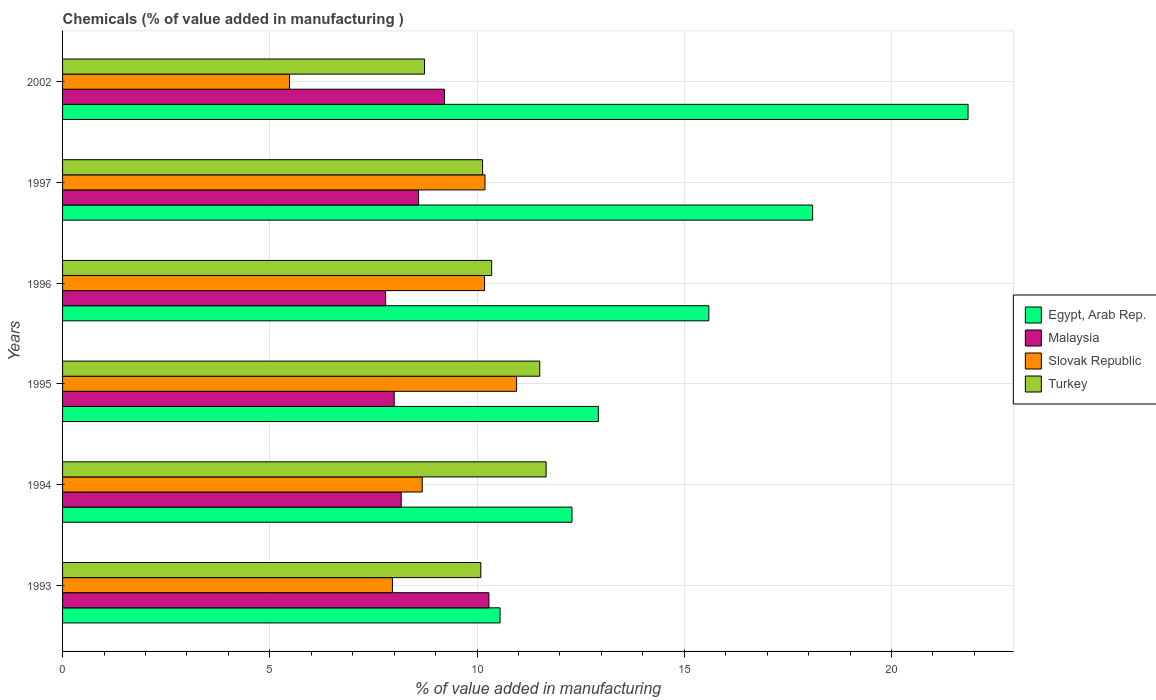How many different coloured bars are there?
Keep it short and to the point. 4. How many bars are there on the 4th tick from the top?
Make the answer very short. 4. How many bars are there on the 4th tick from the bottom?
Provide a succinct answer. 4. What is the value added in manufacturing chemicals in Malaysia in 1997?
Make the answer very short. 8.59. Across all years, what is the maximum value added in manufacturing chemicals in Egypt, Arab Rep.?
Offer a very short reply. 21.85. Across all years, what is the minimum value added in manufacturing chemicals in Turkey?
Ensure brevity in your answer.  8.73. What is the total value added in manufacturing chemicals in Egypt, Arab Rep. in the graph?
Your answer should be very brief. 91.31. What is the difference between the value added in manufacturing chemicals in Malaysia in 1993 and that in 2002?
Your response must be concise. 1.07. What is the difference between the value added in manufacturing chemicals in Slovak Republic in 1997 and the value added in manufacturing chemicals in Turkey in 2002?
Give a very brief answer. 1.46. What is the average value added in manufacturing chemicals in Egypt, Arab Rep. per year?
Your response must be concise. 15.22. In the year 1997, what is the difference between the value added in manufacturing chemicals in Turkey and value added in manufacturing chemicals in Egypt, Arab Rep.?
Offer a terse response. -7.96. What is the ratio of the value added in manufacturing chemicals in Malaysia in 1995 to that in 2002?
Your answer should be very brief. 0.87. Is the value added in manufacturing chemicals in Egypt, Arab Rep. in 1996 less than that in 2002?
Your answer should be very brief. Yes. Is the difference between the value added in manufacturing chemicals in Turkey in 1995 and 1996 greater than the difference between the value added in manufacturing chemicals in Egypt, Arab Rep. in 1995 and 1996?
Your answer should be very brief. Yes. What is the difference between the highest and the second highest value added in manufacturing chemicals in Slovak Republic?
Offer a terse response. 0.76. What is the difference between the highest and the lowest value added in manufacturing chemicals in Egypt, Arab Rep.?
Your answer should be very brief. 11.29. What does the 3rd bar from the top in 1993 represents?
Offer a very short reply. Malaysia. What does the 3rd bar from the bottom in 1995 represents?
Offer a very short reply. Slovak Republic. How many years are there in the graph?
Your response must be concise. 6. Where does the legend appear in the graph?
Ensure brevity in your answer.  Center right. What is the title of the graph?
Keep it short and to the point. Chemicals (% of value added in manufacturing ). What is the label or title of the X-axis?
Provide a short and direct response. % of value added in manufacturing. What is the % of value added in manufacturing of Egypt, Arab Rep. in 1993?
Your answer should be compact. 10.56. What is the % of value added in manufacturing of Malaysia in 1993?
Give a very brief answer. 10.29. What is the % of value added in manufacturing in Slovak Republic in 1993?
Give a very brief answer. 7.96. What is the % of value added in manufacturing in Turkey in 1993?
Offer a very short reply. 10.09. What is the % of value added in manufacturing in Egypt, Arab Rep. in 1994?
Your response must be concise. 12.29. What is the % of value added in manufacturing in Malaysia in 1994?
Offer a very short reply. 8.17. What is the % of value added in manufacturing in Slovak Republic in 1994?
Provide a succinct answer. 8.68. What is the % of value added in manufacturing in Turkey in 1994?
Ensure brevity in your answer.  11.67. What is the % of value added in manufacturing in Egypt, Arab Rep. in 1995?
Your answer should be very brief. 12.93. What is the % of value added in manufacturing of Malaysia in 1995?
Make the answer very short. 8. What is the % of value added in manufacturing in Slovak Republic in 1995?
Keep it short and to the point. 10.96. What is the % of value added in manufacturing of Turkey in 1995?
Offer a terse response. 11.51. What is the % of value added in manufacturing in Egypt, Arab Rep. in 1996?
Ensure brevity in your answer.  15.59. What is the % of value added in manufacturing in Malaysia in 1996?
Offer a terse response. 7.79. What is the % of value added in manufacturing in Slovak Republic in 1996?
Provide a succinct answer. 10.18. What is the % of value added in manufacturing of Turkey in 1996?
Your answer should be compact. 10.35. What is the % of value added in manufacturing of Egypt, Arab Rep. in 1997?
Provide a succinct answer. 18.1. What is the % of value added in manufacturing of Malaysia in 1997?
Ensure brevity in your answer.  8.59. What is the % of value added in manufacturing in Slovak Republic in 1997?
Your response must be concise. 10.19. What is the % of value added in manufacturing of Turkey in 1997?
Provide a succinct answer. 10.13. What is the % of value added in manufacturing in Egypt, Arab Rep. in 2002?
Make the answer very short. 21.85. What is the % of value added in manufacturing in Malaysia in 2002?
Your answer should be compact. 9.21. What is the % of value added in manufacturing in Slovak Republic in 2002?
Ensure brevity in your answer.  5.48. What is the % of value added in manufacturing in Turkey in 2002?
Provide a succinct answer. 8.73. Across all years, what is the maximum % of value added in manufacturing of Egypt, Arab Rep.?
Your response must be concise. 21.85. Across all years, what is the maximum % of value added in manufacturing in Malaysia?
Your answer should be very brief. 10.29. Across all years, what is the maximum % of value added in manufacturing of Slovak Republic?
Offer a very short reply. 10.96. Across all years, what is the maximum % of value added in manufacturing of Turkey?
Keep it short and to the point. 11.67. Across all years, what is the minimum % of value added in manufacturing of Egypt, Arab Rep.?
Give a very brief answer. 10.56. Across all years, what is the minimum % of value added in manufacturing of Malaysia?
Offer a terse response. 7.79. Across all years, what is the minimum % of value added in manufacturing of Slovak Republic?
Your answer should be compact. 5.48. Across all years, what is the minimum % of value added in manufacturing of Turkey?
Make the answer very short. 8.73. What is the total % of value added in manufacturing in Egypt, Arab Rep. in the graph?
Offer a terse response. 91.31. What is the total % of value added in manufacturing of Malaysia in the graph?
Your response must be concise. 52.06. What is the total % of value added in manufacturing in Slovak Republic in the graph?
Your response must be concise. 53.44. What is the total % of value added in manufacturing in Turkey in the graph?
Provide a succinct answer. 62.49. What is the difference between the % of value added in manufacturing in Egypt, Arab Rep. in 1993 and that in 1994?
Keep it short and to the point. -1.74. What is the difference between the % of value added in manufacturing in Malaysia in 1993 and that in 1994?
Provide a succinct answer. 2.12. What is the difference between the % of value added in manufacturing of Slovak Republic in 1993 and that in 1994?
Keep it short and to the point. -0.72. What is the difference between the % of value added in manufacturing of Turkey in 1993 and that in 1994?
Your response must be concise. -1.58. What is the difference between the % of value added in manufacturing in Egypt, Arab Rep. in 1993 and that in 1995?
Provide a succinct answer. -2.37. What is the difference between the % of value added in manufacturing in Malaysia in 1993 and that in 1995?
Provide a short and direct response. 2.29. What is the difference between the % of value added in manufacturing in Slovak Republic in 1993 and that in 1995?
Ensure brevity in your answer.  -3. What is the difference between the % of value added in manufacturing of Turkey in 1993 and that in 1995?
Keep it short and to the point. -1.42. What is the difference between the % of value added in manufacturing in Egypt, Arab Rep. in 1993 and that in 1996?
Your answer should be very brief. -5.04. What is the difference between the % of value added in manufacturing in Malaysia in 1993 and that in 1996?
Your answer should be very brief. 2.49. What is the difference between the % of value added in manufacturing of Slovak Republic in 1993 and that in 1996?
Your answer should be compact. -2.22. What is the difference between the % of value added in manufacturing in Turkey in 1993 and that in 1996?
Give a very brief answer. -0.26. What is the difference between the % of value added in manufacturing of Egypt, Arab Rep. in 1993 and that in 1997?
Keep it short and to the point. -7.54. What is the difference between the % of value added in manufacturing in Malaysia in 1993 and that in 1997?
Ensure brevity in your answer.  1.7. What is the difference between the % of value added in manufacturing of Slovak Republic in 1993 and that in 1997?
Your answer should be compact. -2.23. What is the difference between the % of value added in manufacturing of Turkey in 1993 and that in 1997?
Your answer should be compact. -0.04. What is the difference between the % of value added in manufacturing of Egypt, Arab Rep. in 1993 and that in 2002?
Provide a short and direct response. -11.29. What is the difference between the % of value added in manufacturing of Malaysia in 1993 and that in 2002?
Ensure brevity in your answer.  1.07. What is the difference between the % of value added in manufacturing of Slovak Republic in 1993 and that in 2002?
Offer a terse response. 2.48. What is the difference between the % of value added in manufacturing in Turkey in 1993 and that in 2002?
Provide a succinct answer. 1.36. What is the difference between the % of value added in manufacturing of Egypt, Arab Rep. in 1994 and that in 1995?
Keep it short and to the point. -0.64. What is the difference between the % of value added in manufacturing in Malaysia in 1994 and that in 1995?
Ensure brevity in your answer.  0.17. What is the difference between the % of value added in manufacturing in Slovak Republic in 1994 and that in 1995?
Give a very brief answer. -2.28. What is the difference between the % of value added in manufacturing in Turkey in 1994 and that in 1995?
Offer a terse response. 0.15. What is the difference between the % of value added in manufacturing in Egypt, Arab Rep. in 1994 and that in 1996?
Provide a succinct answer. -3.3. What is the difference between the % of value added in manufacturing in Malaysia in 1994 and that in 1996?
Ensure brevity in your answer.  0.38. What is the difference between the % of value added in manufacturing of Slovak Republic in 1994 and that in 1996?
Provide a succinct answer. -1.51. What is the difference between the % of value added in manufacturing of Turkey in 1994 and that in 1996?
Provide a succinct answer. 1.31. What is the difference between the % of value added in manufacturing in Egypt, Arab Rep. in 1994 and that in 1997?
Offer a very short reply. -5.81. What is the difference between the % of value added in manufacturing in Malaysia in 1994 and that in 1997?
Offer a very short reply. -0.42. What is the difference between the % of value added in manufacturing of Slovak Republic in 1994 and that in 1997?
Ensure brevity in your answer.  -1.51. What is the difference between the % of value added in manufacturing of Turkey in 1994 and that in 1997?
Make the answer very short. 1.53. What is the difference between the % of value added in manufacturing of Egypt, Arab Rep. in 1994 and that in 2002?
Offer a terse response. -9.56. What is the difference between the % of value added in manufacturing of Malaysia in 1994 and that in 2002?
Provide a succinct answer. -1.04. What is the difference between the % of value added in manufacturing in Slovak Republic in 1994 and that in 2002?
Your answer should be very brief. 3.2. What is the difference between the % of value added in manufacturing of Turkey in 1994 and that in 2002?
Offer a very short reply. 2.93. What is the difference between the % of value added in manufacturing of Egypt, Arab Rep. in 1995 and that in 1996?
Provide a succinct answer. -2.66. What is the difference between the % of value added in manufacturing of Malaysia in 1995 and that in 1996?
Your answer should be very brief. 0.21. What is the difference between the % of value added in manufacturing in Slovak Republic in 1995 and that in 1996?
Offer a terse response. 0.77. What is the difference between the % of value added in manufacturing of Turkey in 1995 and that in 1996?
Your response must be concise. 1.16. What is the difference between the % of value added in manufacturing of Egypt, Arab Rep. in 1995 and that in 1997?
Offer a terse response. -5.17. What is the difference between the % of value added in manufacturing of Malaysia in 1995 and that in 1997?
Keep it short and to the point. -0.59. What is the difference between the % of value added in manufacturing of Slovak Republic in 1995 and that in 1997?
Make the answer very short. 0.76. What is the difference between the % of value added in manufacturing of Turkey in 1995 and that in 1997?
Your response must be concise. 1.38. What is the difference between the % of value added in manufacturing of Egypt, Arab Rep. in 1995 and that in 2002?
Provide a short and direct response. -8.92. What is the difference between the % of value added in manufacturing in Malaysia in 1995 and that in 2002?
Make the answer very short. -1.21. What is the difference between the % of value added in manufacturing in Slovak Republic in 1995 and that in 2002?
Offer a terse response. 5.48. What is the difference between the % of value added in manufacturing of Turkey in 1995 and that in 2002?
Offer a very short reply. 2.78. What is the difference between the % of value added in manufacturing of Egypt, Arab Rep. in 1996 and that in 1997?
Make the answer very short. -2.5. What is the difference between the % of value added in manufacturing of Malaysia in 1996 and that in 1997?
Provide a short and direct response. -0.79. What is the difference between the % of value added in manufacturing of Slovak Republic in 1996 and that in 1997?
Provide a short and direct response. -0.01. What is the difference between the % of value added in manufacturing of Turkey in 1996 and that in 1997?
Offer a terse response. 0.22. What is the difference between the % of value added in manufacturing in Egypt, Arab Rep. in 1996 and that in 2002?
Offer a terse response. -6.26. What is the difference between the % of value added in manufacturing in Malaysia in 1996 and that in 2002?
Your answer should be very brief. -1.42. What is the difference between the % of value added in manufacturing of Slovak Republic in 1996 and that in 2002?
Your answer should be very brief. 4.71. What is the difference between the % of value added in manufacturing of Turkey in 1996 and that in 2002?
Provide a succinct answer. 1.62. What is the difference between the % of value added in manufacturing in Egypt, Arab Rep. in 1997 and that in 2002?
Your answer should be very brief. -3.75. What is the difference between the % of value added in manufacturing of Malaysia in 1997 and that in 2002?
Your answer should be compact. -0.63. What is the difference between the % of value added in manufacturing in Slovak Republic in 1997 and that in 2002?
Your answer should be compact. 4.72. What is the difference between the % of value added in manufacturing of Turkey in 1997 and that in 2002?
Ensure brevity in your answer.  1.4. What is the difference between the % of value added in manufacturing of Egypt, Arab Rep. in 1993 and the % of value added in manufacturing of Malaysia in 1994?
Offer a very short reply. 2.39. What is the difference between the % of value added in manufacturing in Egypt, Arab Rep. in 1993 and the % of value added in manufacturing in Slovak Republic in 1994?
Your response must be concise. 1.88. What is the difference between the % of value added in manufacturing in Egypt, Arab Rep. in 1993 and the % of value added in manufacturing in Turkey in 1994?
Offer a very short reply. -1.11. What is the difference between the % of value added in manufacturing of Malaysia in 1993 and the % of value added in manufacturing of Slovak Republic in 1994?
Provide a short and direct response. 1.61. What is the difference between the % of value added in manufacturing of Malaysia in 1993 and the % of value added in manufacturing of Turkey in 1994?
Offer a very short reply. -1.38. What is the difference between the % of value added in manufacturing in Slovak Republic in 1993 and the % of value added in manufacturing in Turkey in 1994?
Your answer should be very brief. -3.71. What is the difference between the % of value added in manufacturing of Egypt, Arab Rep. in 1993 and the % of value added in manufacturing of Malaysia in 1995?
Provide a succinct answer. 2.55. What is the difference between the % of value added in manufacturing in Egypt, Arab Rep. in 1993 and the % of value added in manufacturing in Slovak Republic in 1995?
Provide a short and direct response. -0.4. What is the difference between the % of value added in manufacturing of Egypt, Arab Rep. in 1993 and the % of value added in manufacturing of Turkey in 1995?
Provide a succinct answer. -0.96. What is the difference between the % of value added in manufacturing in Malaysia in 1993 and the % of value added in manufacturing in Slovak Republic in 1995?
Your answer should be very brief. -0.67. What is the difference between the % of value added in manufacturing in Malaysia in 1993 and the % of value added in manufacturing in Turkey in 1995?
Make the answer very short. -1.23. What is the difference between the % of value added in manufacturing of Slovak Republic in 1993 and the % of value added in manufacturing of Turkey in 1995?
Provide a short and direct response. -3.55. What is the difference between the % of value added in manufacturing of Egypt, Arab Rep. in 1993 and the % of value added in manufacturing of Malaysia in 1996?
Provide a short and direct response. 2.76. What is the difference between the % of value added in manufacturing in Egypt, Arab Rep. in 1993 and the % of value added in manufacturing in Slovak Republic in 1996?
Provide a short and direct response. 0.37. What is the difference between the % of value added in manufacturing in Egypt, Arab Rep. in 1993 and the % of value added in manufacturing in Turkey in 1996?
Your answer should be very brief. 0.2. What is the difference between the % of value added in manufacturing in Malaysia in 1993 and the % of value added in manufacturing in Slovak Republic in 1996?
Offer a very short reply. 0.1. What is the difference between the % of value added in manufacturing in Malaysia in 1993 and the % of value added in manufacturing in Turkey in 1996?
Make the answer very short. -0.07. What is the difference between the % of value added in manufacturing in Slovak Republic in 1993 and the % of value added in manufacturing in Turkey in 1996?
Ensure brevity in your answer.  -2.39. What is the difference between the % of value added in manufacturing of Egypt, Arab Rep. in 1993 and the % of value added in manufacturing of Malaysia in 1997?
Provide a succinct answer. 1.97. What is the difference between the % of value added in manufacturing in Egypt, Arab Rep. in 1993 and the % of value added in manufacturing in Slovak Republic in 1997?
Give a very brief answer. 0.36. What is the difference between the % of value added in manufacturing in Egypt, Arab Rep. in 1993 and the % of value added in manufacturing in Turkey in 1997?
Provide a short and direct response. 0.42. What is the difference between the % of value added in manufacturing of Malaysia in 1993 and the % of value added in manufacturing of Slovak Republic in 1997?
Your response must be concise. 0.1. What is the difference between the % of value added in manufacturing in Malaysia in 1993 and the % of value added in manufacturing in Turkey in 1997?
Your answer should be very brief. 0.15. What is the difference between the % of value added in manufacturing of Slovak Republic in 1993 and the % of value added in manufacturing of Turkey in 1997?
Keep it short and to the point. -2.18. What is the difference between the % of value added in manufacturing of Egypt, Arab Rep. in 1993 and the % of value added in manufacturing of Malaysia in 2002?
Offer a very short reply. 1.34. What is the difference between the % of value added in manufacturing in Egypt, Arab Rep. in 1993 and the % of value added in manufacturing in Slovak Republic in 2002?
Offer a terse response. 5.08. What is the difference between the % of value added in manufacturing of Egypt, Arab Rep. in 1993 and the % of value added in manufacturing of Turkey in 2002?
Ensure brevity in your answer.  1.82. What is the difference between the % of value added in manufacturing in Malaysia in 1993 and the % of value added in manufacturing in Slovak Republic in 2002?
Keep it short and to the point. 4.81. What is the difference between the % of value added in manufacturing of Malaysia in 1993 and the % of value added in manufacturing of Turkey in 2002?
Keep it short and to the point. 1.55. What is the difference between the % of value added in manufacturing of Slovak Republic in 1993 and the % of value added in manufacturing of Turkey in 2002?
Give a very brief answer. -0.77. What is the difference between the % of value added in manufacturing in Egypt, Arab Rep. in 1994 and the % of value added in manufacturing in Malaysia in 1995?
Make the answer very short. 4.29. What is the difference between the % of value added in manufacturing of Egypt, Arab Rep. in 1994 and the % of value added in manufacturing of Slovak Republic in 1995?
Make the answer very short. 1.34. What is the difference between the % of value added in manufacturing of Malaysia in 1994 and the % of value added in manufacturing of Slovak Republic in 1995?
Your response must be concise. -2.79. What is the difference between the % of value added in manufacturing in Malaysia in 1994 and the % of value added in manufacturing in Turkey in 1995?
Offer a very short reply. -3.34. What is the difference between the % of value added in manufacturing in Slovak Republic in 1994 and the % of value added in manufacturing in Turkey in 1995?
Your response must be concise. -2.84. What is the difference between the % of value added in manufacturing of Egypt, Arab Rep. in 1994 and the % of value added in manufacturing of Malaysia in 1996?
Ensure brevity in your answer.  4.5. What is the difference between the % of value added in manufacturing of Egypt, Arab Rep. in 1994 and the % of value added in manufacturing of Slovak Republic in 1996?
Give a very brief answer. 2.11. What is the difference between the % of value added in manufacturing of Egypt, Arab Rep. in 1994 and the % of value added in manufacturing of Turkey in 1996?
Offer a terse response. 1.94. What is the difference between the % of value added in manufacturing in Malaysia in 1994 and the % of value added in manufacturing in Slovak Republic in 1996?
Make the answer very short. -2.01. What is the difference between the % of value added in manufacturing of Malaysia in 1994 and the % of value added in manufacturing of Turkey in 1996?
Your answer should be very brief. -2.18. What is the difference between the % of value added in manufacturing of Slovak Republic in 1994 and the % of value added in manufacturing of Turkey in 1996?
Provide a short and direct response. -1.68. What is the difference between the % of value added in manufacturing of Egypt, Arab Rep. in 1994 and the % of value added in manufacturing of Malaysia in 1997?
Make the answer very short. 3.7. What is the difference between the % of value added in manufacturing of Egypt, Arab Rep. in 1994 and the % of value added in manufacturing of Slovak Republic in 1997?
Make the answer very short. 2.1. What is the difference between the % of value added in manufacturing of Egypt, Arab Rep. in 1994 and the % of value added in manufacturing of Turkey in 1997?
Provide a succinct answer. 2.16. What is the difference between the % of value added in manufacturing of Malaysia in 1994 and the % of value added in manufacturing of Slovak Republic in 1997?
Ensure brevity in your answer.  -2.02. What is the difference between the % of value added in manufacturing of Malaysia in 1994 and the % of value added in manufacturing of Turkey in 1997?
Offer a very short reply. -1.96. What is the difference between the % of value added in manufacturing of Slovak Republic in 1994 and the % of value added in manufacturing of Turkey in 1997?
Give a very brief answer. -1.46. What is the difference between the % of value added in manufacturing in Egypt, Arab Rep. in 1994 and the % of value added in manufacturing in Malaysia in 2002?
Keep it short and to the point. 3.08. What is the difference between the % of value added in manufacturing in Egypt, Arab Rep. in 1994 and the % of value added in manufacturing in Slovak Republic in 2002?
Make the answer very short. 6.82. What is the difference between the % of value added in manufacturing in Egypt, Arab Rep. in 1994 and the % of value added in manufacturing in Turkey in 2002?
Offer a terse response. 3.56. What is the difference between the % of value added in manufacturing of Malaysia in 1994 and the % of value added in manufacturing of Slovak Republic in 2002?
Keep it short and to the point. 2.69. What is the difference between the % of value added in manufacturing in Malaysia in 1994 and the % of value added in manufacturing in Turkey in 2002?
Your response must be concise. -0.56. What is the difference between the % of value added in manufacturing in Slovak Republic in 1994 and the % of value added in manufacturing in Turkey in 2002?
Your response must be concise. -0.06. What is the difference between the % of value added in manufacturing in Egypt, Arab Rep. in 1995 and the % of value added in manufacturing in Malaysia in 1996?
Ensure brevity in your answer.  5.13. What is the difference between the % of value added in manufacturing in Egypt, Arab Rep. in 1995 and the % of value added in manufacturing in Slovak Republic in 1996?
Offer a very short reply. 2.75. What is the difference between the % of value added in manufacturing in Egypt, Arab Rep. in 1995 and the % of value added in manufacturing in Turkey in 1996?
Your response must be concise. 2.58. What is the difference between the % of value added in manufacturing of Malaysia in 1995 and the % of value added in manufacturing of Slovak Republic in 1996?
Give a very brief answer. -2.18. What is the difference between the % of value added in manufacturing in Malaysia in 1995 and the % of value added in manufacturing in Turkey in 1996?
Offer a very short reply. -2.35. What is the difference between the % of value added in manufacturing in Slovak Republic in 1995 and the % of value added in manufacturing in Turkey in 1996?
Give a very brief answer. 0.6. What is the difference between the % of value added in manufacturing in Egypt, Arab Rep. in 1995 and the % of value added in manufacturing in Malaysia in 1997?
Your answer should be compact. 4.34. What is the difference between the % of value added in manufacturing of Egypt, Arab Rep. in 1995 and the % of value added in manufacturing of Slovak Republic in 1997?
Make the answer very short. 2.74. What is the difference between the % of value added in manufacturing in Egypt, Arab Rep. in 1995 and the % of value added in manufacturing in Turkey in 1997?
Your answer should be very brief. 2.79. What is the difference between the % of value added in manufacturing of Malaysia in 1995 and the % of value added in manufacturing of Slovak Republic in 1997?
Give a very brief answer. -2.19. What is the difference between the % of value added in manufacturing in Malaysia in 1995 and the % of value added in manufacturing in Turkey in 1997?
Provide a short and direct response. -2.13. What is the difference between the % of value added in manufacturing of Slovak Republic in 1995 and the % of value added in manufacturing of Turkey in 1997?
Provide a short and direct response. 0.82. What is the difference between the % of value added in manufacturing of Egypt, Arab Rep. in 1995 and the % of value added in manufacturing of Malaysia in 2002?
Offer a very short reply. 3.71. What is the difference between the % of value added in manufacturing of Egypt, Arab Rep. in 1995 and the % of value added in manufacturing of Slovak Republic in 2002?
Make the answer very short. 7.45. What is the difference between the % of value added in manufacturing of Egypt, Arab Rep. in 1995 and the % of value added in manufacturing of Turkey in 2002?
Ensure brevity in your answer.  4.19. What is the difference between the % of value added in manufacturing in Malaysia in 1995 and the % of value added in manufacturing in Slovak Republic in 2002?
Provide a succinct answer. 2.53. What is the difference between the % of value added in manufacturing of Malaysia in 1995 and the % of value added in manufacturing of Turkey in 2002?
Keep it short and to the point. -0.73. What is the difference between the % of value added in manufacturing in Slovak Republic in 1995 and the % of value added in manufacturing in Turkey in 2002?
Provide a short and direct response. 2.22. What is the difference between the % of value added in manufacturing of Egypt, Arab Rep. in 1996 and the % of value added in manufacturing of Malaysia in 1997?
Ensure brevity in your answer.  7. What is the difference between the % of value added in manufacturing of Egypt, Arab Rep. in 1996 and the % of value added in manufacturing of Slovak Republic in 1997?
Provide a succinct answer. 5.4. What is the difference between the % of value added in manufacturing of Egypt, Arab Rep. in 1996 and the % of value added in manufacturing of Turkey in 1997?
Make the answer very short. 5.46. What is the difference between the % of value added in manufacturing in Malaysia in 1996 and the % of value added in manufacturing in Slovak Republic in 1997?
Keep it short and to the point. -2.4. What is the difference between the % of value added in manufacturing of Malaysia in 1996 and the % of value added in manufacturing of Turkey in 1997?
Give a very brief answer. -2.34. What is the difference between the % of value added in manufacturing of Slovak Republic in 1996 and the % of value added in manufacturing of Turkey in 1997?
Your answer should be compact. 0.05. What is the difference between the % of value added in manufacturing in Egypt, Arab Rep. in 1996 and the % of value added in manufacturing in Malaysia in 2002?
Provide a short and direct response. 6.38. What is the difference between the % of value added in manufacturing of Egypt, Arab Rep. in 1996 and the % of value added in manufacturing of Slovak Republic in 2002?
Give a very brief answer. 10.12. What is the difference between the % of value added in manufacturing in Egypt, Arab Rep. in 1996 and the % of value added in manufacturing in Turkey in 2002?
Your answer should be compact. 6.86. What is the difference between the % of value added in manufacturing in Malaysia in 1996 and the % of value added in manufacturing in Slovak Republic in 2002?
Ensure brevity in your answer.  2.32. What is the difference between the % of value added in manufacturing of Malaysia in 1996 and the % of value added in manufacturing of Turkey in 2002?
Offer a very short reply. -0.94. What is the difference between the % of value added in manufacturing of Slovak Republic in 1996 and the % of value added in manufacturing of Turkey in 2002?
Offer a terse response. 1.45. What is the difference between the % of value added in manufacturing of Egypt, Arab Rep. in 1997 and the % of value added in manufacturing of Malaysia in 2002?
Offer a terse response. 8.88. What is the difference between the % of value added in manufacturing of Egypt, Arab Rep. in 1997 and the % of value added in manufacturing of Slovak Republic in 2002?
Your answer should be very brief. 12.62. What is the difference between the % of value added in manufacturing in Egypt, Arab Rep. in 1997 and the % of value added in manufacturing in Turkey in 2002?
Your response must be concise. 9.36. What is the difference between the % of value added in manufacturing in Malaysia in 1997 and the % of value added in manufacturing in Slovak Republic in 2002?
Your answer should be compact. 3.11. What is the difference between the % of value added in manufacturing of Malaysia in 1997 and the % of value added in manufacturing of Turkey in 2002?
Your answer should be compact. -0.14. What is the difference between the % of value added in manufacturing of Slovak Republic in 1997 and the % of value added in manufacturing of Turkey in 2002?
Offer a very short reply. 1.46. What is the average % of value added in manufacturing of Egypt, Arab Rep. per year?
Your response must be concise. 15.22. What is the average % of value added in manufacturing in Malaysia per year?
Make the answer very short. 8.68. What is the average % of value added in manufacturing of Slovak Republic per year?
Your answer should be compact. 8.91. What is the average % of value added in manufacturing of Turkey per year?
Provide a succinct answer. 10.42. In the year 1993, what is the difference between the % of value added in manufacturing in Egypt, Arab Rep. and % of value added in manufacturing in Malaysia?
Ensure brevity in your answer.  0.27. In the year 1993, what is the difference between the % of value added in manufacturing in Egypt, Arab Rep. and % of value added in manufacturing in Slovak Republic?
Give a very brief answer. 2.6. In the year 1993, what is the difference between the % of value added in manufacturing in Egypt, Arab Rep. and % of value added in manufacturing in Turkey?
Your response must be concise. 0.46. In the year 1993, what is the difference between the % of value added in manufacturing in Malaysia and % of value added in manufacturing in Slovak Republic?
Offer a very short reply. 2.33. In the year 1993, what is the difference between the % of value added in manufacturing in Malaysia and % of value added in manufacturing in Turkey?
Your response must be concise. 0.2. In the year 1993, what is the difference between the % of value added in manufacturing in Slovak Republic and % of value added in manufacturing in Turkey?
Make the answer very short. -2.13. In the year 1994, what is the difference between the % of value added in manufacturing in Egypt, Arab Rep. and % of value added in manufacturing in Malaysia?
Offer a terse response. 4.12. In the year 1994, what is the difference between the % of value added in manufacturing of Egypt, Arab Rep. and % of value added in manufacturing of Slovak Republic?
Your answer should be very brief. 3.61. In the year 1994, what is the difference between the % of value added in manufacturing in Egypt, Arab Rep. and % of value added in manufacturing in Turkey?
Offer a very short reply. 0.62. In the year 1994, what is the difference between the % of value added in manufacturing of Malaysia and % of value added in manufacturing of Slovak Republic?
Your response must be concise. -0.51. In the year 1994, what is the difference between the % of value added in manufacturing in Malaysia and % of value added in manufacturing in Turkey?
Offer a very short reply. -3.5. In the year 1994, what is the difference between the % of value added in manufacturing of Slovak Republic and % of value added in manufacturing of Turkey?
Offer a very short reply. -2.99. In the year 1995, what is the difference between the % of value added in manufacturing of Egypt, Arab Rep. and % of value added in manufacturing of Malaysia?
Ensure brevity in your answer.  4.93. In the year 1995, what is the difference between the % of value added in manufacturing of Egypt, Arab Rep. and % of value added in manufacturing of Slovak Republic?
Your answer should be very brief. 1.97. In the year 1995, what is the difference between the % of value added in manufacturing in Egypt, Arab Rep. and % of value added in manufacturing in Turkey?
Your response must be concise. 1.41. In the year 1995, what is the difference between the % of value added in manufacturing in Malaysia and % of value added in manufacturing in Slovak Republic?
Offer a very short reply. -2.95. In the year 1995, what is the difference between the % of value added in manufacturing of Malaysia and % of value added in manufacturing of Turkey?
Provide a succinct answer. -3.51. In the year 1995, what is the difference between the % of value added in manufacturing of Slovak Republic and % of value added in manufacturing of Turkey?
Provide a short and direct response. -0.56. In the year 1996, what is the difference between the % of value added in manufacturing of Egypt, Arab Rep. and % of value added in manufacturing of Malaysia?
Ensure brevity in your answer.  7.8. In the year 1996, what is the difference between the % of value added in manufacturing of Egypt, Arab Rep. and % of value added in manufacturing of Slovak Republic?
Ensure brevity in your answer.  5.41. In the year 1996, what is the difference between the % of value added in manufacturing of Egypt, Arab Rep. and % of value added in manufacturing of Turkey?
Your answer should be compact. 5.24. In the year 1996, what is the difference between the % of value added in manufacturing of Malaysia and % of value added in manufacturing of Slovak Republic?
Ensure brevity in your answer.  -2.39. In the year 1996, what is the difference between the % of value added in manufacturing in Malaysia and % of value added in manufacturing in Turkey?
Offer a very short reply. -2.56. In the year 1996, what is the difference between the % of value added in manufacturing of Slovak Republic and % of value added in manufacturing of Turkey?
Provide a succinct answer. -0.17. In the year 1997, what is the difference between the % of value added in manufacturing in Egypt, Arab Rep. and % of value added in manufacturing in Malaysia?
Offer a terse response. 9.51. In the year 1997, what is the difference between the % of value added in manufacturing of Egypt, Arab Rep. and % of value added in manufacturing of Slovak Republic?
Provide a short and direct response. 7.91. In the year 1997, what is the difference between the % of value added in manufacturing in Egypt, Arab Rep. and % of value added in manufacturing in Turkey?
Provide a short and direct response. 7.96. In the year 1997, what is the difference between the % of value added in manufacturing of Malaysia and % of value added in manufacturing of Slovak Republic?
Your response must be concise. -1.6. In the year 1997, what is the difference between the % of value added in manufacturing in Malaysia and % of value added in manufacturing in Turkey?
Ensure brevity in your answer.  -1.55. In the year 1997, what is the difference between the % of value added in manufacturing of Slovak Republic and % of value added in manufacturing of Turkey?
Offer a terse response. 0.06. In the year 2002, what is the difference between the % of value added in manufacturing of Egypt, Arab Rep. and % of value added in manufacturing of Malaysia?
Offer a terse response. 12.63. In the year 2002, what is the difference between the % of value added in manufacturing in Egypt, Arab Rep. and % of value added in manufacturing in Slovak Republic?
Provide a short and direct response. 16.37. In the year 2002, what is the difference between the % of value added in manufacturing of Egypt, Arab Rep. and % of value added in manufacturing of Turkey?
Offer a terse response. 13.11. In the year 2002, what is the difference between the % of value added in manufacturing of Malaysia and % of value added in manufacturing of Slovak Republic?
Provide a succinct answer. 3.74. In the year 2002, what is the difference between the % of value added in manufacturing of Malaysia and % of value added in manufacturing of Turkey?
Provide a succinct answer. 0.48. In the year 2002, what is the difference between the % of value added in manufacturing in Slovak Republic and % of value added in manufacturing in Turkey?
Give a very brief answer. -3.26. What is the ratio of the % of value added in manufacturing in Egypt, Arab Rep. in 1993 to that in 1994?
Your answer should be very brief. 0.86. What is the ratio of the % of value added in manufacturing of Malaysia in 1993 to that in 1994?
Ensure brevity in your answer.  1.26. What is the ratio of the % of value added in manufacturing of Slovak Republic in 1993 to that in 1994?
Your response must be concise. 0.92. What is the ratio of the % of value added in manufacturing of Turkey in 1993 to that in 1994?
Provide a succinct answer. 0.86. What is the ratio of the % of value added in manufacturing in Egypt, Arab Rep. in 1993 to that in 1995?
Your answer should be very brief. 0.82. What is the ratio of the % of value added in manufacturing in Slovak Republic in 1993 to that in 1995?
Ensure brevity in your answer.  0.73. What is the ratio of the % of value added in manufacturing of Turkey in 1993 to that in 1995?
Give a very brief answer. 0.88. What is the ratio of the % of value added in manufacturing of Egypt, Arab Rep. in 1993 to that in 1996?
Your answer should be compact. 0.68. What is the ratio of the % of value added in manufacturing of Malaysia in 1993 to that in 1996?
Keep it short and to the point. 1.32. What is the ratio of the % of value added in manufacturing in Slovak Republic in 1993 to that in 1996?
Your answer should be compact. 0.78. What is the ratio of the % of value added in manufacturing in Turkey in 1993 to that in 1996?
Ensure brevity in your answer.  0.97. What is the ratio of the % of value added in manufacturing of Egypt, Arab Rep. in 1993 to that in 1997?
Make the answer very short. 0.58. What is the ratio of the % of value added in manufacturing of Malaysia in 1993 to that in 1997?
Provide a succinct answer. 1.2. What is the ratio of the % of value added in manufacturing in Slovak Republic in 1993 to that in 1997?
Offer a very short reply. 0.78. What is the ratio of the % of value added in manufacturing of Egypt, Arab Rep. in 1993 to that in 2002?
Offer a terse response. 0.48. What is the ratio of the % of value added in manufacturing of Malaysia in 1993 to that in 2002?
Offer a very short reply. 1.12. What is the ratio of the % of value added in manufacturing of Slovak Republic in 1993 to that in 2002?
Your response must be concise. 1.45. What is the ratio of the % of value added in manufacturing in Turkey in 1993 to that in 2002?
Provide a short and direct response. 1.16. What is the ratio of the % of value added in manufacturing of Egypt, Arab Rep. in 1994 to that in 1995?
Make the answer very short. 0.95. What is the ratio of the % of value added in manufacturing of Malaysia in 1994 to that in 1995?
Offer a very short reply. 1.02. What is the ratio of the % of value added in manufacturing in Slovak Republic in 1994 to that in 1995?
Keep it short and to the point. 0.79. What is the ratio of the % of value added in manufacturing in Turkey in 1994 to that in 1995?
Ensure brevity in your answer.  1.01. What is the ratio of the % of value added in manufacturing in Egypt, Arab Rep. in 1994 to that in 1996?
Your answer should be compact. 0.79. What is the ratio of the % of value added in manufacturing in Malaysia in 1994 to that in 1996?
Provide a succinct answer. 1.05. What is the ratio of the % of value added in manufacturing of Slovak Republic in 1994 to that in 1996?
Offer a terse response. 0.85. What is the ratio of the % of value added in manufacturing in Turkey in 1994 to that in 1996?
Provide a short and direct response. 1.13. What is the ratio of the % of value added in manufacturing in Egypt, Arab Rep. in 1994 to that in 1997?
Keep it short and to the point. 0.68. What is the ratio of the % of value added in manufacturing of Malaysia in 1994 to that in 1997?
Offer a terse response. 0.95. What is the ratio of the % of value added in manufacturing of Slovak Republic in 1994 to that in 1997?
Provide a short and direct response. 0.85. What is the ratio of the % of value added in manufacturing in Turkey in 1994 to that in 1997?
Keep it short and to the point. 1.15. What is the ratio of the % of value added in manufacturing in Egypt, Arab Rep. in 1994 to that in 2002?
Keep it short and to the point. 0.56. What is the ratio of the % of value added in manufacturing in Malaysia in 1994 to that in 2002?
Your response must be concise. 0.89. What is the ratio of the % of value added in manufacturing of Slovak Republic in 1994 to that in 2002?
Your response must be concise. 1.58. What is the ratio of the % of value added in manufacturing of Turkey in 1994 to that in 2002?
Keep it short and to the point. 1.34. What is the ratio of the % of value added in manufacturing of Egypt, Arab Rep. in 1995 to that in 1996?
Offer a very short reply. 0.83. What is the ratio of the % of value added in manufacturing in Malaysia in 1995 to that in 1996?
Ensure brevity in your answer.  1.03. What is the ratio of the % of value added in manufacturing in Slovak Republic in 1995 to that in 1996?
Keep it short and to the point. 1.08. What is the ratio of the % of value added in manufacturing in Turkey in 1995 to that in 1996?
Your response must be concise. 1.11. What is the ratio of the % of value added in manufacturing of Egypt, Arab Rep. in 1995 to that in 1997?
Give a very brief answer. 0.71. What is the ratio of the % of value added in manufacturing in Malaysia in 1995 to that in 1997?
Give a very brief answer. 0.93. What is the ratio of the % of value added in manufacturing of Slovak Republic in 1995 to that in 1997?
Your answer should be very brief. 1.07. What is the ratio of the % of value added in manufacturing in Turkey in 1995 to that in 1997?
Your answer should be compact. 1.14. What is the ratio of the % of value added in manufacturing in Egypt, Arab Rep. in 1995 to that in 2002?
Give a very brief answer. 0.59. What is the ratio of the % of value added in manufacturing of Malaysia in 1995 to that in 2002?
Make the answer very short. 0.87. What is the ratio of the % of value added in manufacturing in Slovak Republic in 1995 to that in 2002?
Ensure brevity in your answer.  2. What is the ratio of the % of value added in manufacturing in Turkey in 1995 to that in 2002?
Keep it short and to the point. 1.32. What is the ratio of the % of value added in manufacturing in Egypt, Arab Rep. in 1996 to that in 1997?
Keep it short and to the point. 0.86. What is the ratio of the % of value added in manufacturing in Malaysia in 1996 to that in 1997?
Provide a succinct answer. 0.91. What is the ratio of the % of value added in manufacturing in Slovak Republic in 1996 to that in 1997?
Provide a succinct answer. 1. What is the ratio of the % of value added in manufacturing of Turkey in 1996 to that in 1997?
Keep it short and to the point. 1.02. What is the ratio of the % of value added in manufacturing of Egypt, Arab Rep. in 1996 to that in 2002?
Provide a short and direct response. 0.71. What is the ratio of the % of value added in manufacturing of Malaysia in 1996 to that in 2002?
Keep it short and to the point. 0.85. What is the ratio of the % of value added in manufacturing of Slovak Republic in 1996 to that in 2002?
Offer a very short reply. 1.86. What is the ratio of the % of value added in manufacturing in Turkey in 1996 to that in 2002?
Provide a short and direct response. 1.19. What is the ratio of the % of value added in manufacturing of Egypt, Arab Rep. in 1997 to that in 2002?
Give a very brief answer. 0.83. What is the ratio of the % of value added in manufacturing of Malaysia in 1997 to that in 2002?
Give a very brief answer. 0.93. What is the ratio of the % of value added in manufacturing in Slovak Republic in 1997 to that in 2002?
Your answer should be very brief. 1.86. What is the ratio of the % of value added in manufacturing of Turkey in 1997 to that in 2002?
Keep it short and to the point. 1.16. What is the difference between the highest and the second highest % of value added in manufacturing in Egypt, Arab Rep.?
Make the answer very short. 3.75. What is the difference between the highest and the second highest % of value added in manufacturing of Malaysia?
Your response must be concise. 1.07. What is the difference between the highest and the second highest % of value added in manufacturing of Slovak Republic?
Give a very brief answer. 0.76. What is the difference between the highest and the second highest % of value added in manufacturing of Turkey?
Ensure brevity in your answer.  0.15. What is the difference between the highest and the lowest % of value added in manufacturing in Egypt, Arab Rep.?
Your answer should be compact. 11.29. What is the difference between the highest and the lowest % of value added in manufacturing of Malaysia?
Your response must be concise. 2.49. What is the difference between the highest and the lowest % of value added in manufacturing in Slovak Republic?
Make the answer very short. 5.48. What is the difference between the highest and the lowest % of value added in manufacturing of Turkey?
Offer a terse response. 2.93. 